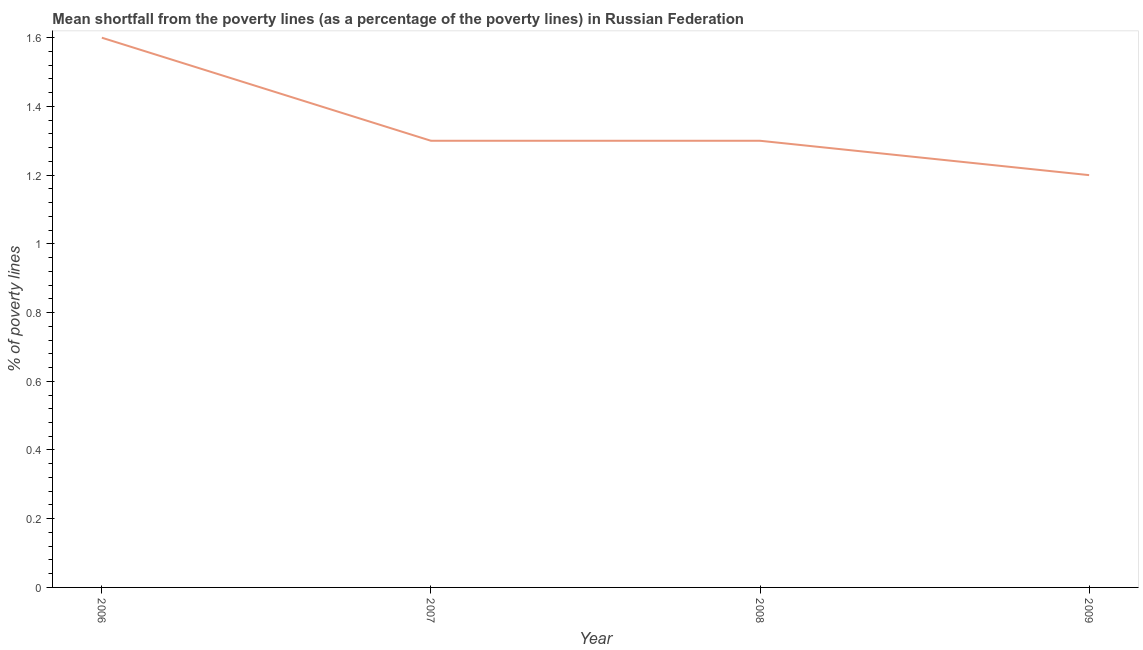In which year was the poverty gap at national poverty lines maximum?
Give a very brief answer. 2006. In which year was the poverty gap at national poverty lines minimum?
Your response must be concise. 2009. What is the difference between the poverty gap at national poverty lines in 2006 and 2007?
Your answer should be compact. 0.3. What is the average poverty gap at national poverty lines per year?
Offer a very short reply. 1.35. What is the median poverty gap at national poverty lines?
Offer a very short reply. 1.3. Do a majority of the years between 2006 and 2008 (inclusive) have poverty gap at national poverty lines greater than 1.2400000000000002 %?
Offer a terse response. Yes. What is the ratio of the poverty gap at national poverty lines in 2006 to that in 2007?
Keep it short and to the point. 1.23. Is the poverty gap at national poverty lines in 2006 less than that in 2008?
Keep it short and to the point. No. What is the difference between the highest and the second highest poverty gap at national poverty lines?
Offer a very short reply. 0.3. Is the sum of the poverty gap at national poverty lines in 2006 and 2009 greater than the maximum poverty gap at national poverty lines across all years?
Make the answer very short. Yes. What is the difference between the highest and the lowest poverty gap at national poverty lines?
Your answer should be compact. 0.4. In how many years, is the poverty gap at national poverty lines greater than the average poverty gap at national poverty lines taken over all years?
Your answer should be very brief. 1. How many years are there in the graph?
Make the answer very short. 4. What is the difference between two consecutive major ticks on the Y-axis?
Give a very brief answer. 0.2. Are the values on the major ticks of Y-axis written in scientific E-notation?
Your answer should be very brief. No. Does the graph contain any zero values?
Keep it short and to the point. No. Does the graph contain grids?
Your answer should be very brief. No. What is the title of the graph?
Offer a very short reply. Mean shortfall from the poverty lines (as a percentage of the poverty lines) in Russian Federation. What is the label or title of the X-axis?
Offer a terse response. Year. What is the label or title of the Y-axis?
Your response must be concise. % of poverty lines. What is the % of poverty lines of 2009?
Your answer should be compact. 1.2. What is the difference between the % of poverty lines in 2006 and 2007?
Provide a succinct answer. 0.3. What is the difference between the % of poverty lines in 2007 and 2008?
Your answer should be compact. 0. What is the difference between the % of poverty lines in 2007 and 2009?
Offer a terse response. 0.1. What is the difference between the % of poverty lines in 2008 and 2009?
Provide a succinct answer. 0.1. What is the ratio of the % of poverty lines in 2006 to that in 2007?
Your answer should be very brief. 1.23. What is the ratio of the % of poverty lines in 2006 to that in 2008?
Ensure brevity in your answer.  1.23. What is the ratio of the % of poverty lines in 2006 to that in 2009?
Provide a succinct answer. 1.33. What is the ratio of the % of poverty lines in 2007 to that in 2009?
Offer a very short reply. 1.08. What is the ratio of the % of poverty lines in 2008 to that in 2009?
Offer a very short reply. 1.08. 